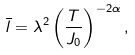Convert formula to latex. <formula><loc_0><loc_0><loc_500><loc_500>\bar { l } = \lambda ^ { 2 } \left ( \frac { T } { J _ { 0 } } \right ) ^ { - 2 \alpha } ,</formula> 